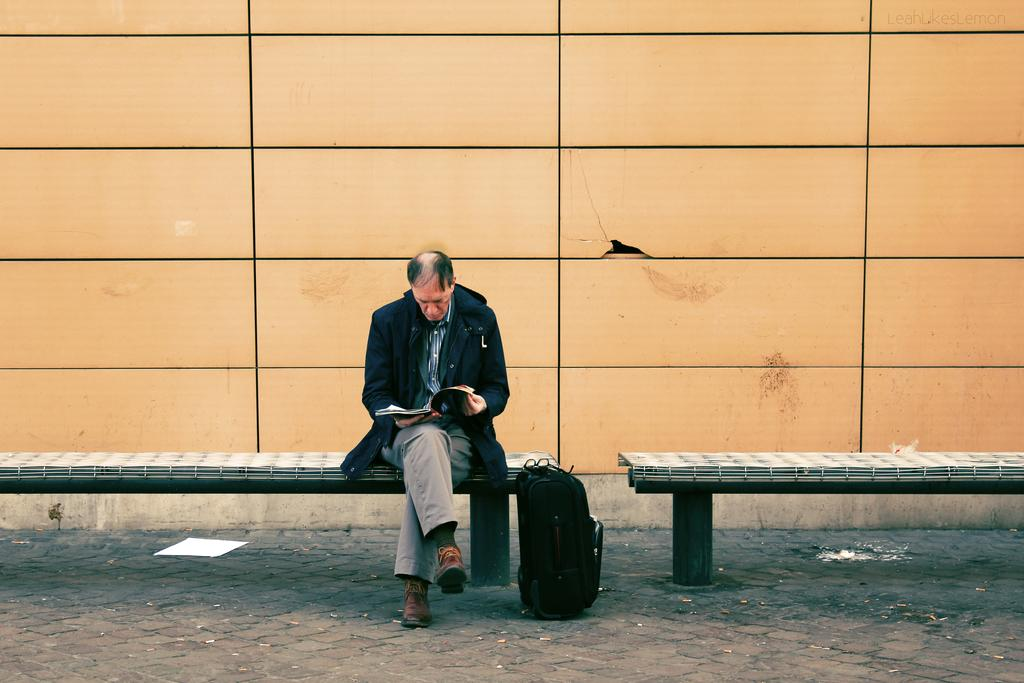What is the person in the image doing? The person in the image is sitting on a bench. What is the person holding in the image? The person is holding a book. Can you describe any other objects in the image? There is a bag in the image. What can be seen in the background of the image? There is a wall in the background of the image. What level of noise is produced by the book in the image? The book in the image does not produce any noise, as it is an inanimate object. 